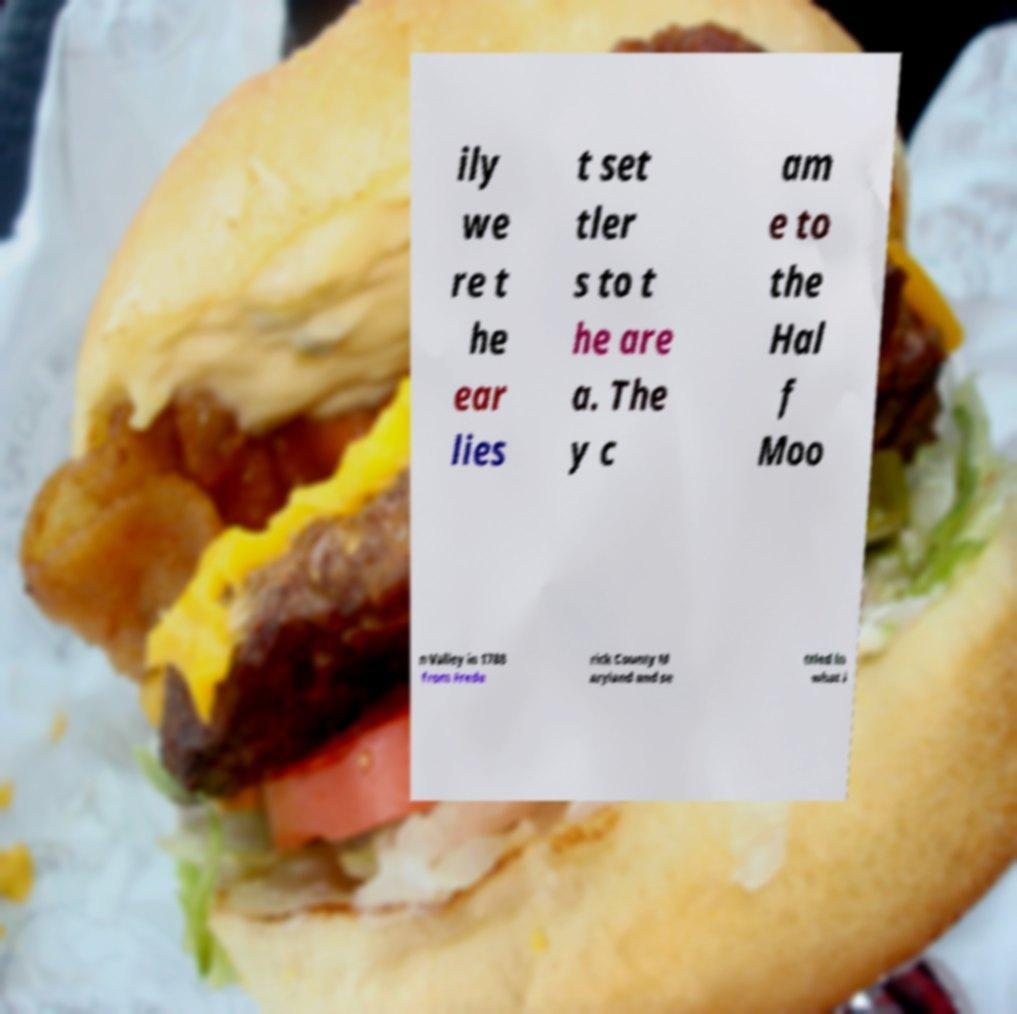Can you accurately transcribe the text from the provided image for me? ily we re t he ear lies t set tler s to t he are a. The y c am e to the Hal f Moo n Valley in 1788 from Frede rick County M aryland and se ttled in what i 